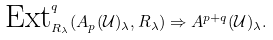<formula> <loc_0><loc_0><loc_500><loc_500>\text {Ext} ^ { q } _ { R _ { \lambda } } ( A _ { p } ( \mathcal { U } ) _ { \lambda } , R _ { \lambda } ) \Rightarrow A ^ { p + q } ( \mathcal { U } ) _ { \lambda } .</formula> 